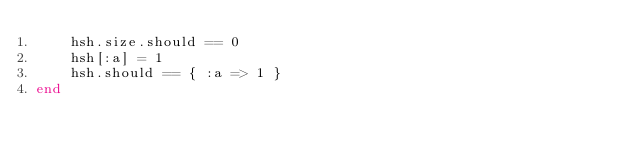Convert code to text. <code><loc_0><loc_0><loc_500><loc_500><_Ruby_>    hsh.size.should == 0
    hsh[:a] = 1
    hsh.should == { :a => 1 }
end
</code> 